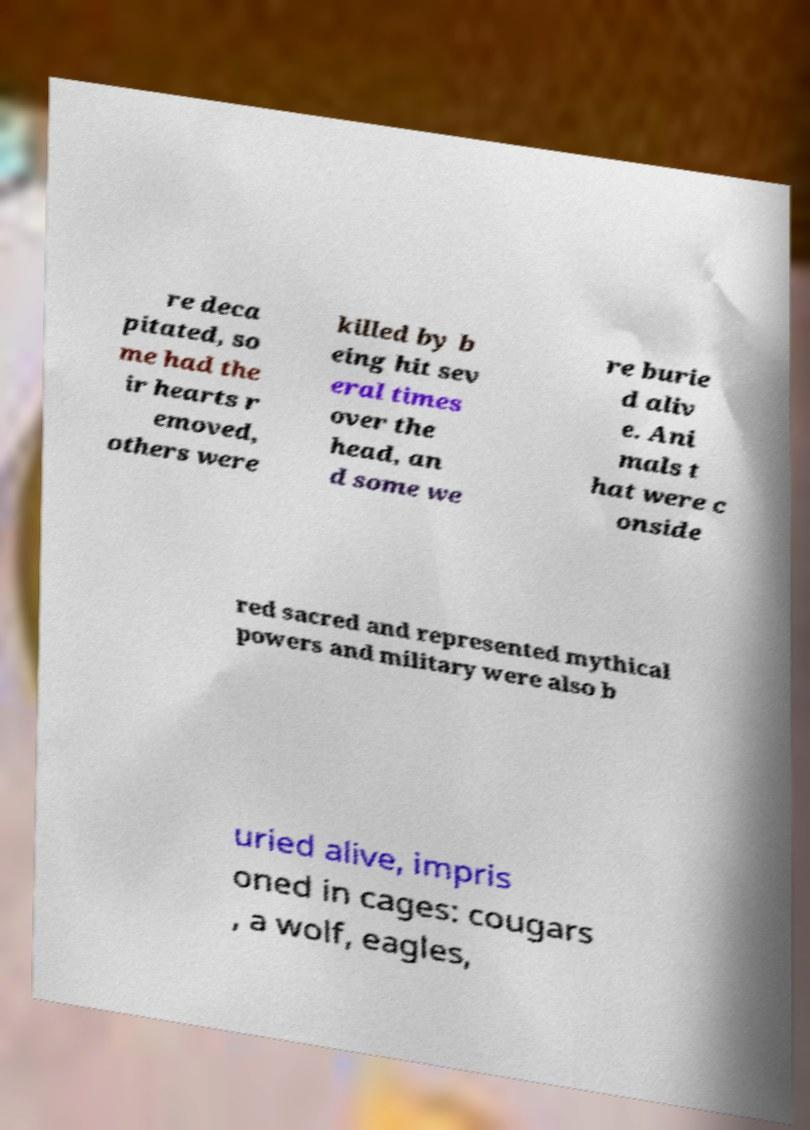Please identify and transcribe the text found in this image. re deca pitated, so me had the ir hearts r emoved, others were killed by b eing hit sev eral times over the head, an d some we re burie d aliv e. Ani mals t hat were c onside red sacred and represented mythical powers and military were also b uried alive, impris oned in cages: cougars , a wolf, eagles, 